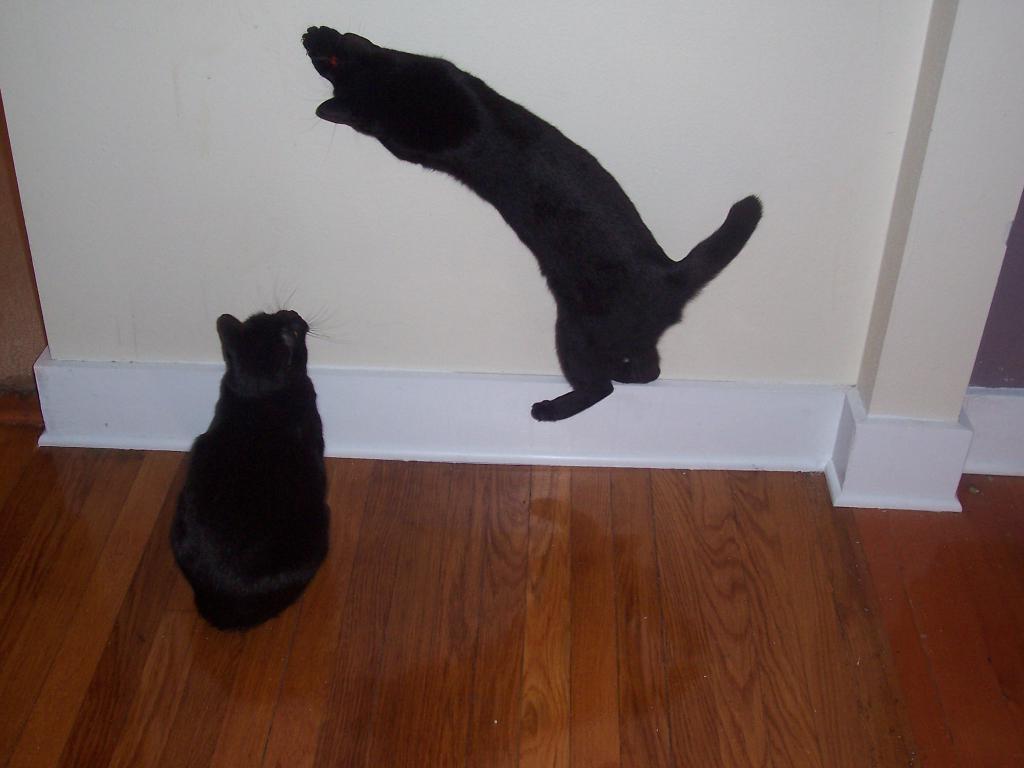Please provide a concise description of this image. In this image, we can see cats and in the background, there is a wall. At the bottom, there is a floor. 